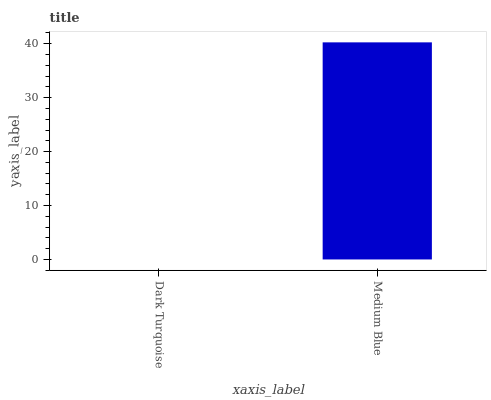Is Dark Turquoise the minimum?
Answer yes or no. Yes. Is Medium Blue the maximum?
Answer yes or no. Yes. Is Medium Blue the minimum?
Answer yes or no. No. Is Medium Blue greater than Dark Turquoise?
Answer yes or no. Yes. Is Dark Turquoise less than Medium Blue?
Answer yes or no. Yes. Is Dark Turquoise greater than Medium Blue?
Answer yes or no. No. Is Medium Blue less than Dark Turquoise?
Answer yes or no. No. Is Medium Blue the high median?
Answer yes or no. Yes. Is Dark Turquoise the low median?
Answer yes or no. Yes. Is Dark Turquoise the high median?
Answer yes or no. No. Is Medium Blue the low median?
Answer yes or no. No. 